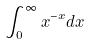<formula> <loc_0><loc_0><loc_500><loc_500>\int _ { 0 } ^ { \infty } x ^ { - x } d x</formula> 